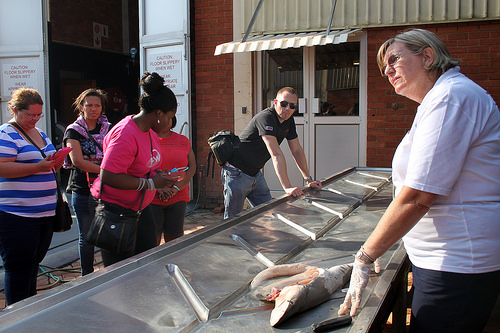<image>
Can you confirm if the fish is on the table? Yes. Looking at the image, I can see the fish is positioned on top of the table, with the table providing support. 